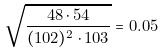Convert formula to latex. <formula><loc_0><loc_0><loc_500><loc_500>\sqrt { \frac { 4 8 \cdot 5 4 } { ( 1 0 2 ) ^ { 2 } \cdot 1 0 3 } } = 0 . 0 5</formula> 